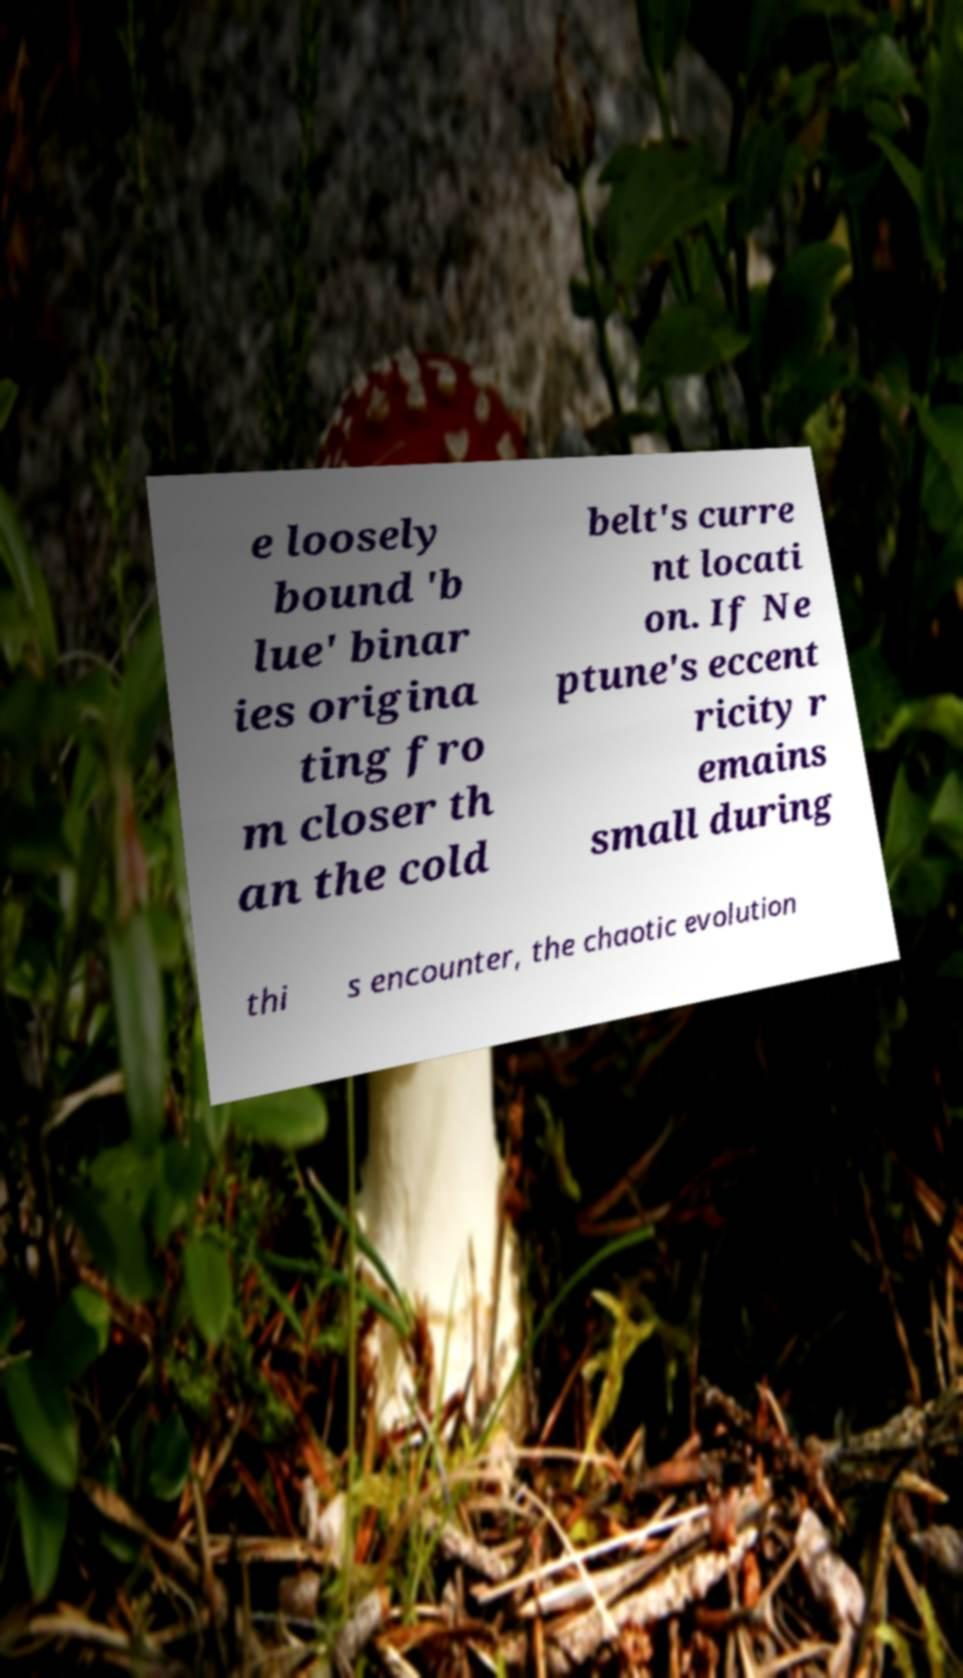Can you read and provide the text displayed in the image?This photo seems to have some interesting text. Can you extract and type it out for me? e loosely bound 'b lue' binar ies origina ting fro m closer th an the cold belt's curre nt locati on. If Ne ptune's eccent ricity r emains small during thi s encounter, the chaotic evolution 